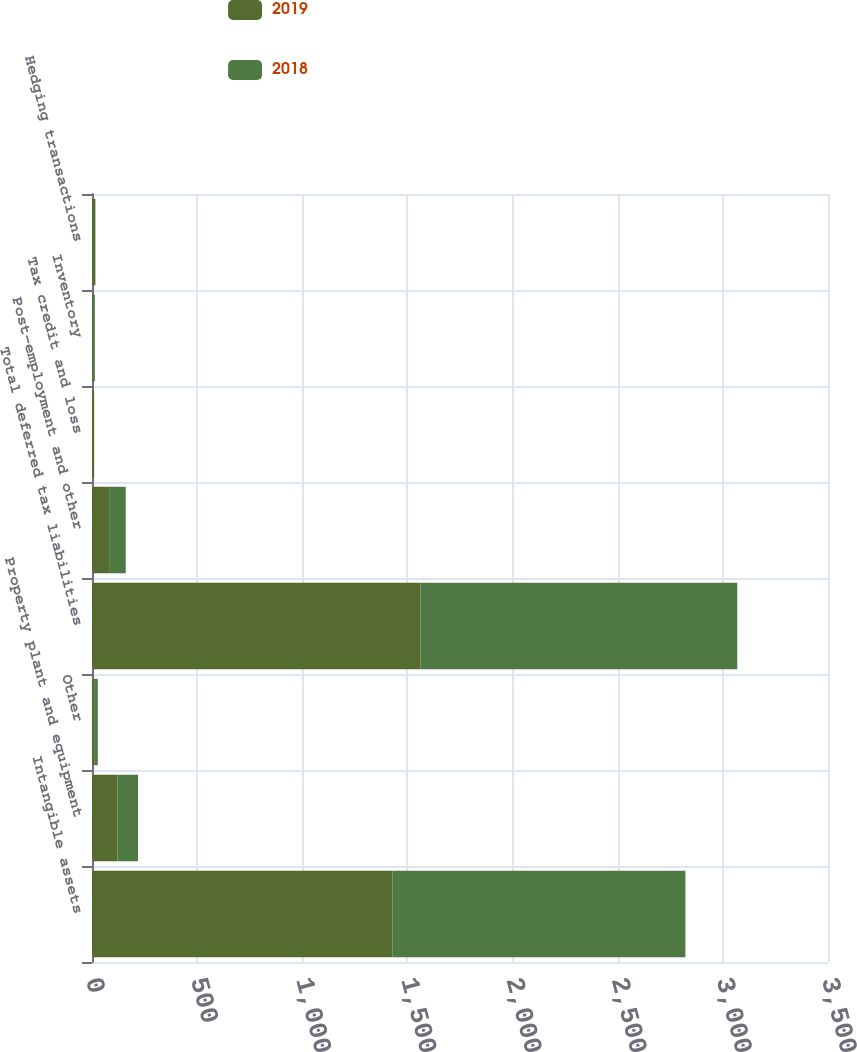<chart> <loc_0><loc_0><loc_500><loc_500><stacked_bar_chart><ecel><fcel>Intangible assets<fcel>Property plant and equipment<fcel>Other<fcel>Total deferred tax liabilities<fcel>Post-employment and other<fcel>Tax credit and loss<fcel>Inventory<fcel>Hedging transactions<nl><fcel>2019<fcel>1428.3<fcel>120.5<fcel>13.4<fcel>1562.2<fcel>84.9<fcel>10<fcel>7.6<fcel>15.6<nl><fcel>2018<fcel>1393.6<fcel>98.5<fcel>14.2<fcel>1506.3<fcel>75.5<fcel>0.2<fcel>5.9<fcel>0.9<nl></chart> 